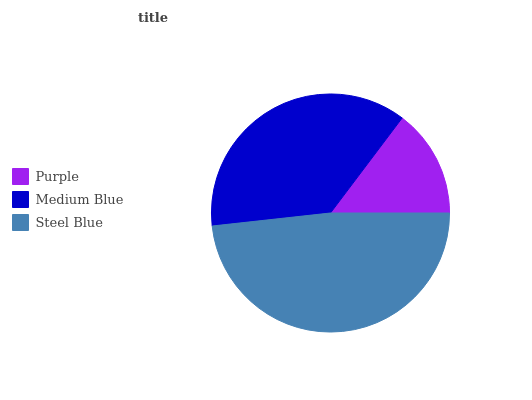Is Purple the minimum?
Answer yes or no. Yes. Is Steel Blue the maximum?
Answer yes or no. Yes. Is Medium Blue the minimum?
Answer yes or no. No. Is Medium Blue the maximum?
Answer yes or no. No. Is Medium Blue greater than Purple?
Answer yes or no. Yes. Is Purple less than Medium Blue?
Answer yes or no. Yes. Is Purple greater than Medium Blue?
Answer yes or no. No. Is Medium Blue less than Purple?
Answer yes or no. No. Is Medium Blue the high median?
Answer yes or no. Yes. Is Medium Blue the low median?
Answer yes or no. Yes. Is Steel Blue the high median?
Answer yes or no. No. Is Purple the low median?
Answer yes or no. No. 